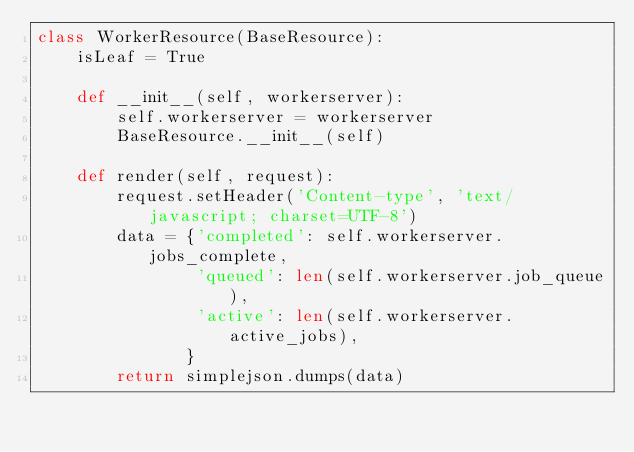Convert code to text. <code><loc_0><loc_0><loc_500><loc_500><_Python_>class WorkerResource(BaseResource):
    isLeaf = True
    
    def __init__(self, workerserver):    
        self.workerserver = workerserver
        BaseResource.__init__(self)
    
    def render(self, request):
        request.setHeader('Content-type', 'text/javascript; charset=UTF-8')
        data = {'completed': self.workerserver.jobs_complete,
                'queued': len(self.workerserver.job_queue),
                'active': len(self.workerserver.active_jobs),
               }
        return simplejson.dumps(data)</code> 